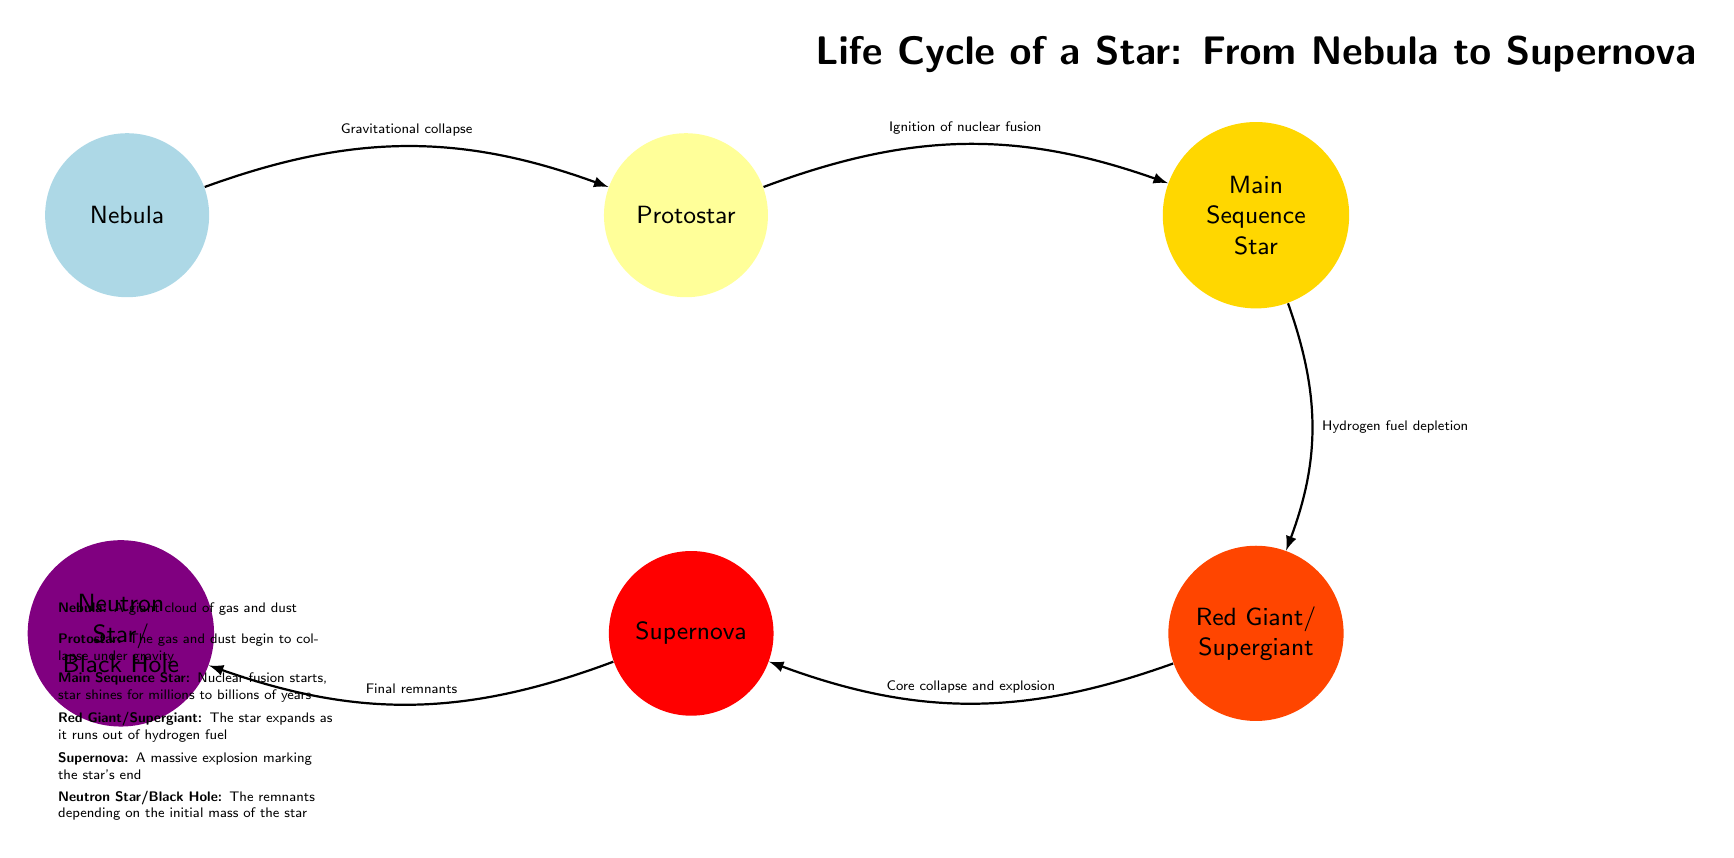What is the first stage in the life cycle of a star? The diagram shows "Nebula" as the first node on the left, indicating it is the initial stage in the life cycle of a star.
Answer: Nebula What process transitions a nebula to a protostar? The diagram indicates "Gravitational collapse" as the transition from the nebula to the protostar node, detailing the process that occurs.
Answer: Gravitational collapse How many main stages of a star's life cycle are identified in the diagram? Counting the nodes from "Nebula" to "Neutron Star/Black Hole", there are five main stages depicted.
Answer: 5 What happens to the star after it enters the main sequence stage? The diagram shows that "Hydrogen fuel depletion" occurs next, indicating this is the subsequent event after the main sequence stage.
Answer: Hydrogen fuel depletion What is the final stage possible for a star, according to this diagram? The diagram lists "Neutron Star/Black Hole" as the ultimate stage on the leftmost node, representing the final remnant of a star.
Answer: Neutron Star/Black Hole What is the primary event that occurs at the red giant/supergiant stage? The transition arrow from the red giant/supergiant node indicates that "Core collapse and explosion" leads to the next stage, which is a significant event at this phase.
Answer: Core collapse and explosion How does a protostar become a main sequence star? The transition labeled "Ignition of nuclear fusion" shows the necessary transformation from the protostar stage to becoming a main sequence star.
Answer: Ignition of nuclear fusion What type of explosion occurs at the supernova stage? The diagram specifies "A massive explosion marking the star's end" as the event at the supernova stage, indicating the nature of this event.
Answer: A massive explosion marking the star's end 